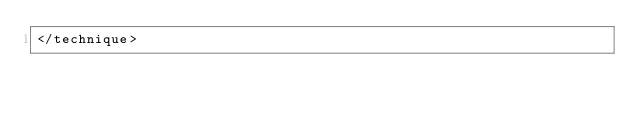<code> <loc_0><loc_0><loc_500><loc_500><_XML_></technique>
</code> 